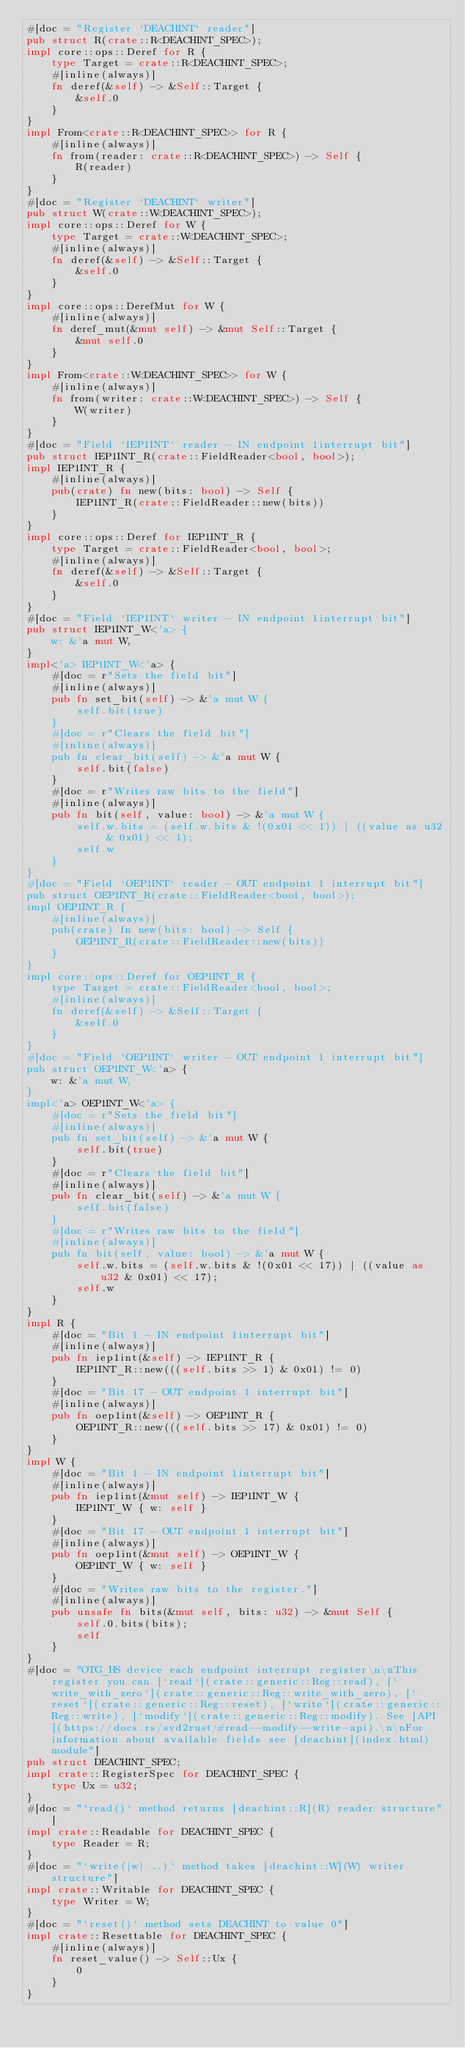Convert code to text. <code><loc_0><loc_0><loc_500><loc_500><_Rust_>#[doc = "Register `DEACHINT` reader"]
pub struct R(crate::R<DEACHINT_SPEC>);
impl core::ops::Deref for R {
    type Target = crate::R<DEACHINT_SPEC>;
    #[inline(always)]
    fn deref(&self) -> &Self::Target {
        &self.0
    }
}
impl From<crate::R<DEACHINT_SPEC>> for R {
    #[inline(always)]
    fn from(reader: crate::R<DEACHINT_SPEC>) -> Self {
        R(reader)
    }
}
#[doc = "Register `DEACHINT` writer"]
pub struct W(crate::W<DEACHINT_SPEC>);
impl core::ops::Deref for W {
    type Target = crate::W<DEACHINT_SPEC>;
    #[inline(always)]
    fn deref(&self) -> &Self::Target {
        &self.0
    }
}
impl core::ops::DerefMut for W {
    #[inline(always)]
    fn deref_mut(&mut self) -> &mut Self::Target {
        &mut self.0
    }
}
impl From<crate::W<DEACHINT_SPEC>> for W {
    #[inline(always)]
    fn from(writer: crate::W<DEACHINT_SPEC>) -> Self {
        W(writer)
    }
}
#[doc = "Field `IEP1INT` reader - IN endpoint 1interrupt bit"]
pub struct IEP1INT_R(crate::FieldReader<bool, bool>);
impl IEP1INT_R {
    #[inline(always)]
    pub(crate) fn new(bits: bool) -> Self {
        IEP1INT_R(crate::FieldReader::new(bits))
    }
}
impl core::ops::Deref for IEP1INT_R {
    type Target = crate::FieldReader<bool, bool>;
    #[inline(always)]
    fn deref(&self) -> &Self::Target {
        &self.0
    }
}
#[doc = "Field `IEP1INT` writer - IN endpoint 1interrupt bit"]
pub struct IEP1INT_W<'a> {
    w: &'a mut W,
}
impl<'a> IEP1INT_W<'a> {
    #[doc = r"Sets the field bit"]
    #[inline(always)]
    pub fn set_bit(self) -> &'a mut W {
        self.bit(true)
    }
    #[doc = r"Clears the field bit"]
    #[inline(always)]
    pub fn clear_bit(self) -> &'a mut W {
        self.bit(false)
    }
    #[doc = r"Writes raw bits to the field"]
    #[inline(always)]
    pub fn bit(self, value: bool) -> &'a mut W {
        self.w.bits = (self.w.bits & !(0x01 << 1)) | ((value as u32 & 0x01) << 1);
        self.w
    }
}
#[doc = "Field `OEP1INT` reader - OUT endpoint 1 interrupt bit"]
pub struct OEP1INT_R(crate::FieldReader<bool, bool>);
impl OEP1INT_R {
    #[inline(always)]
    pub(crate) fn new(bits: bool) -> Self {
        OEP1INT_R(crate::FieldReader::new(bits))
    }
}
impl core::ops::Deref for OEP1INT_R {
    type Target = crate::FieldReader<bool, bool>;
    #[inline(always)]
    fn deref(&self) -> &Self::Target {
        &self.0
    }
}
#[doc = "Field `OEP1INT` writer - OUT endpoint 1 interrupt bit"]
pub struct OEP1INT_W<'a> {
    w: &'a mut W,
}
impl<'a> OEP1INT_W<'a> {
    #[doc = r"Sets the field bit"]
    #[inline(always)]
    pub fn set_bit(self) -> &'a mut W {
        self.bit(true)
    }
    #[doc = r"Clears the field bit"]
    #[inline(always)]
    pub fn clear_bit(self) -> &'a mut W {
        self.bit(false)
    }
    #[doc = r"Writes raw bits to the field"]
    #[inline(always)]
    pub fn bit(self, value: bool) -> &'a mut W {
        self.w.bits = (self.w.bits & !(0x01 << 17)) | ((value as u32 & 0x01) << 17);
        self.w
    }
}
impl R {
    #[doc = "Bit 1 - IN endpoint 1interrupt bit"]
    #[inline(always)]
    pub fn iep1int(&self) -> IEP1INT_R {
        IEP1INT_R::new(((self.bits >> 1) & 0x01) != 0)
    }
    #[doc = "Bit 17 - OUT endpoint 1 interrupt bit"]
    #[inline(always)]
    pub fn oep1int(&self) -> OEP1INT_R {
        OEP1INT_R::new(((self.bits >> 17) & 0x01) != 0)
    }
}
impl W {
    #[doc = "Bit 1 - IN endpoint 1interrupt bit"]
    #[inline(always)]
    pub fn iep1int(&mut self) -> IEP1INT_W {
        IEP1INT_W { w: self }
    }
    #[doc = "Bit 17 - OUT endpoint 1 interrupt bit"]
    #[inline(always)]
    pub fn oep1int(&mut self) -> OEP1INT_W {
        OEP1INT_W { w: self }
    }
    #[doc = "Writes raw bits to the register."]
    #[inline(always)]
    pub unsafe fn bits(&mut self, bits: u32) -> &mut Self {
        self.0.bits(bits);
        self
    }
}
#[doc = "OTG_HS device each endpoint interrupt register\n\nThis register you can [`read`](crate::generic::Reg::read), [`write_with_zero`](crate::generic::Reg::write_with_zero), [`reset`](crate::generic::Reg::reset), [`write`](crate::generic::Reg::write), [`modify`](crate::generic::Reg::modify). See [API](https://docs.rs/svd2rust/#read--modify--write-api).\n\nFor information about available fields see [deachint](index.html) module"]
pub struct DEACHINT_SPEC;
impl crate::RegisterSpec for DEACHINT_SPEC {
    type Ux = u32;
}
#[doc = "`read()` method returns [deachint::R](R) reader structure"]
impl crate::Readable for DEACHINT_SPEC {
    type Reader = R;
}
#[doc = "`write(|w| ..)` method takes [deachint::W](W) writer structure"]
impl crate::Writable for DEACHINT_SPEC {
    type Writer = W;
}
#[doc = "`reset()` method sets DEACHINT to value 0"]
impl crate::Resettable for DEACHINT_SPEC {
    #[inline(always)]
    fn reset_value() -> Self::Ux {
        0
    }
}
</code> 